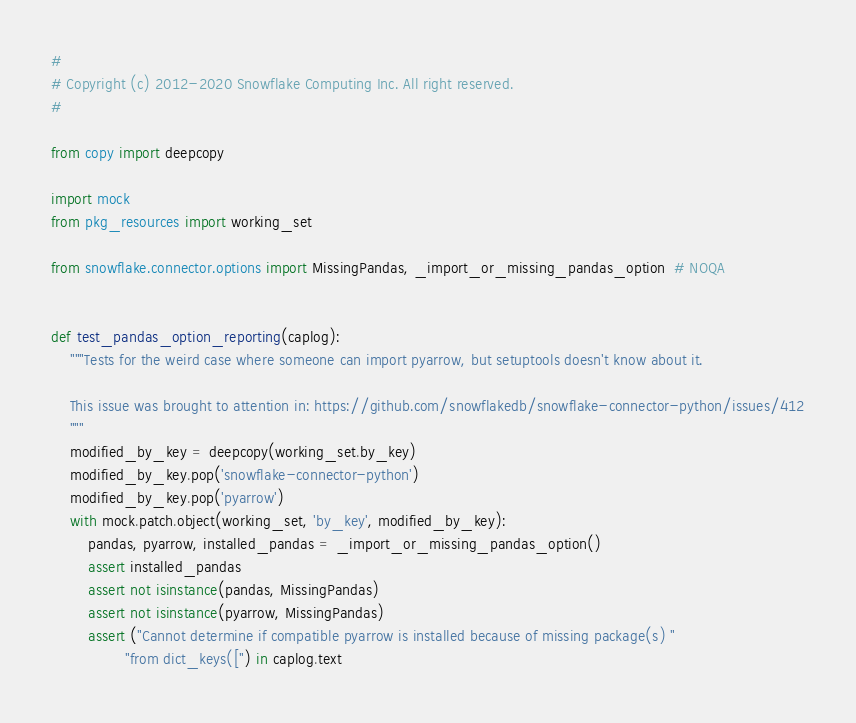<code> <loc_0><loc_0><loc_500><loc_500><_Python_>#
# Copyright (c) 2012-2020 Snowflake Computing Inc. All right reserved.
#

from copy import deepcopy

import mock
from pkg_resources import working_set

from snowflake.connector.options import MissingPandas, _import_or_missing_pandas_option  # NOQA


def test_pandas_option_reporting(caplog):
    """Tests for the weird case where someone can import pyarrow, but setuptools doesn't know about it.

    This issue was brought to attention in: https://github.com/snowflakedb/snowflake-connector-python/issues/412
    """
    modified_by_key = deepcopy(working_set.by_key)
    modified_by_key.pop('snowflake-connector-python')
    modified_by_key.pop('pyarrow')
    with mock.patch.object(working_set, 'by_key', modified_by_key):
        pandas, pyarrow, installed_pandas = _import_or_missing_pandas_option()
        assert installed_pandas
        assert not isinstance(pandas, MissingPandas)
        assert not isinstance(pyarrow, MissingPandas)
        assert ("Cannot determine if compatible pyarrow is installed because of missing package(s) "
                "from dict_keys([") in caplog.text
</code> 